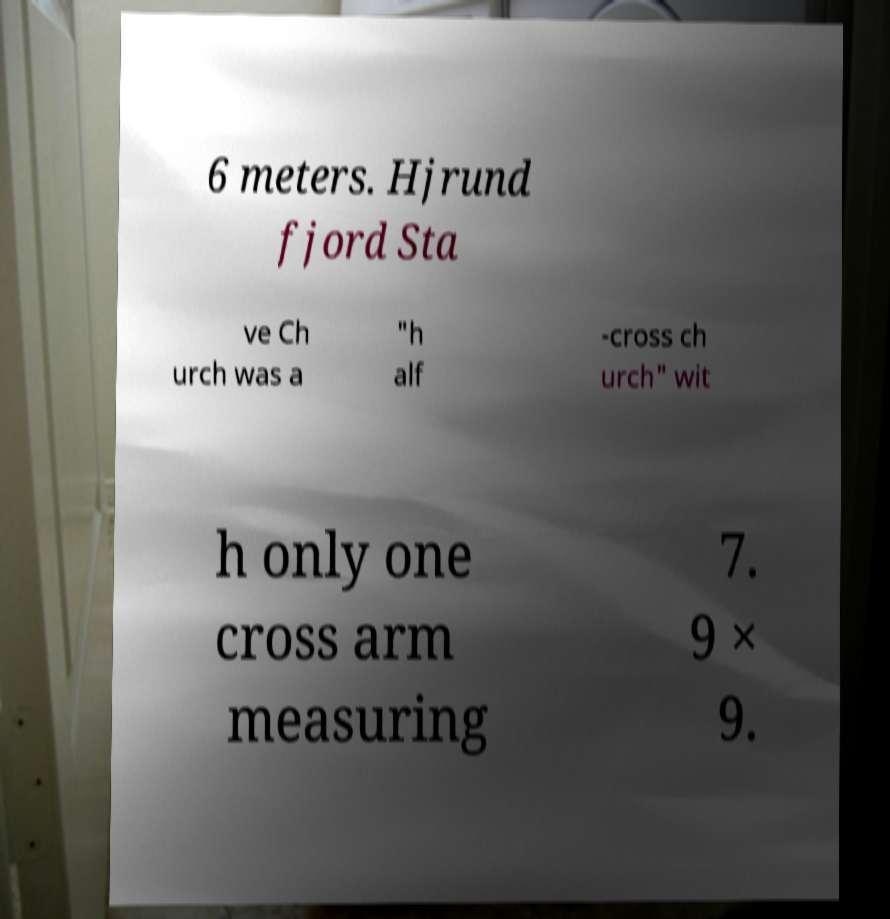I need the written content from this picture converted into text. Can you do that? 6 meters. Hjrund fjord Sta ve Ch urch was a "h alf -cross ch urch" wit h only one cross arm measuring 7. 9 × 9. 